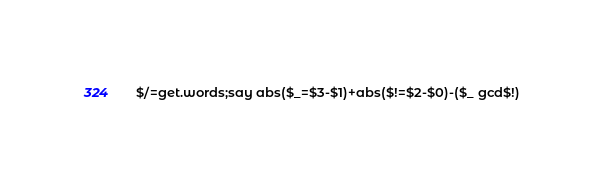Convert code to text. <code><loc_0><loc_0><loc_500><loc_500><_Perl_>$/=get.words;say abs($_=$3-$1)+abs($!=$2-$0)-($_ gcd$!)</code> 